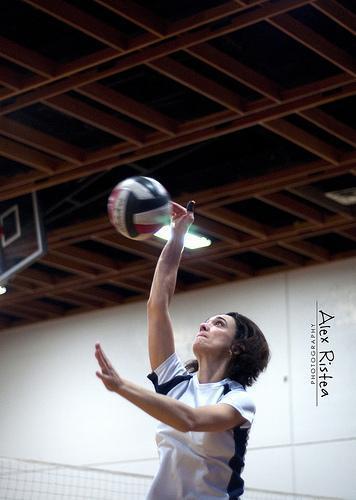How many people are in the photo?
Give a very brief answer. 1. 